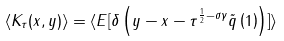<formula> <loc_0><loc_0><loc_500><loc_500>\langle K _ { \tau } ( x , y ) \rangle = \langle E [ \delta \left ( y - x - \tau ^ { \frac { 1 } { 2 } - \sigma \gamma } \tilde { q } \left ( 1 \right ) \right ) ] \rangle</formula> 